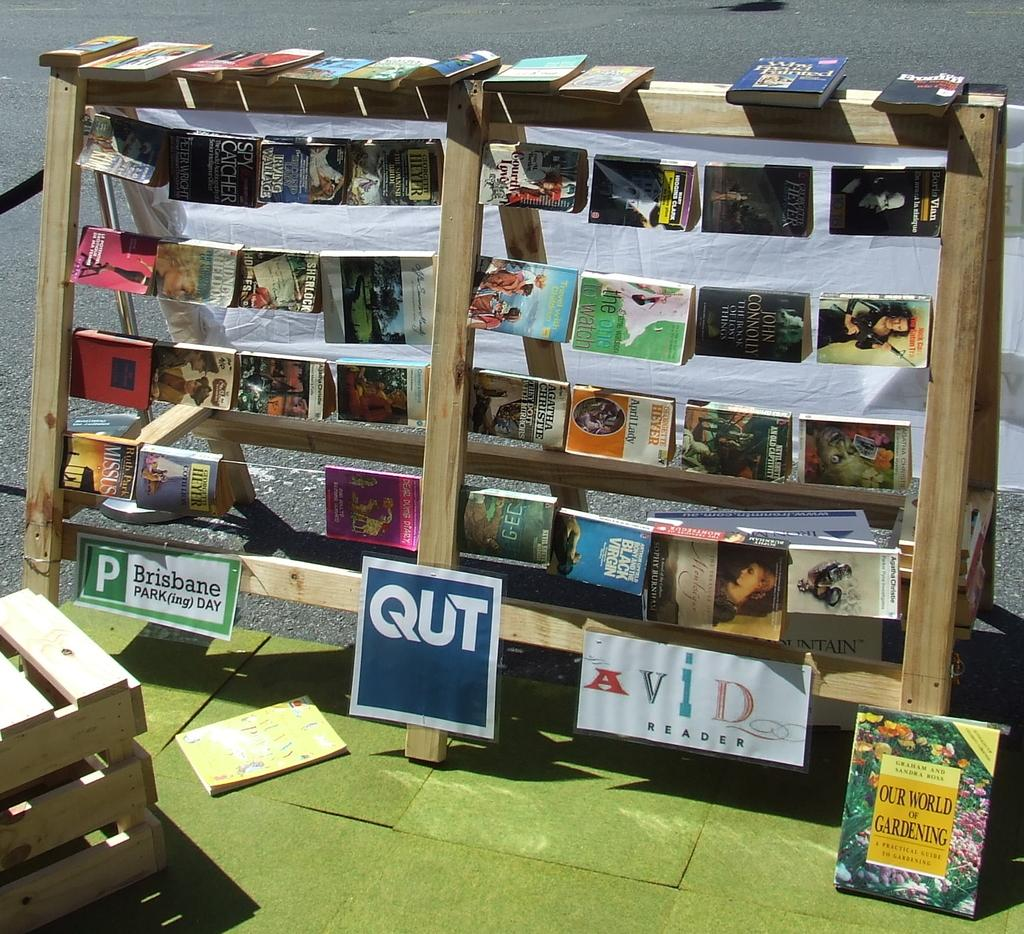<image>
Present a compact description of the photo's key features. Some books are on display outdoors on shelves, including one on gardening that is leaning against the display. 